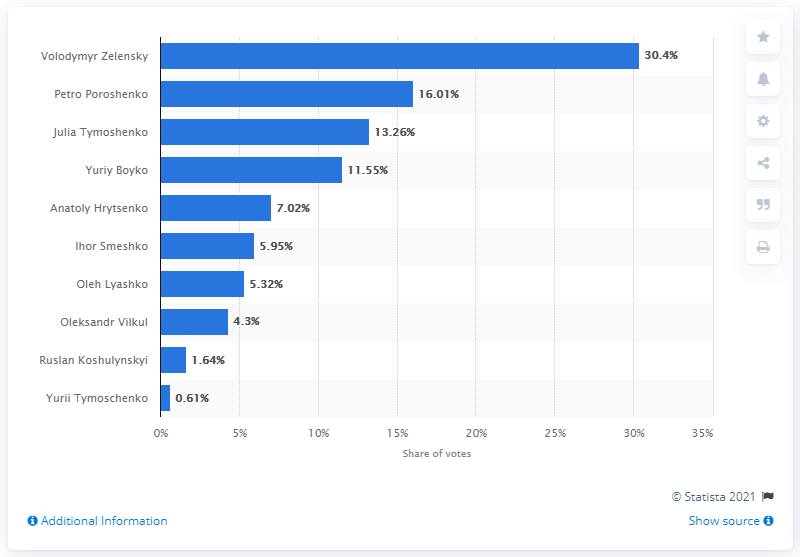Identify some key points in this picture. Petro Poroshenko is the current president of Ukraine. 